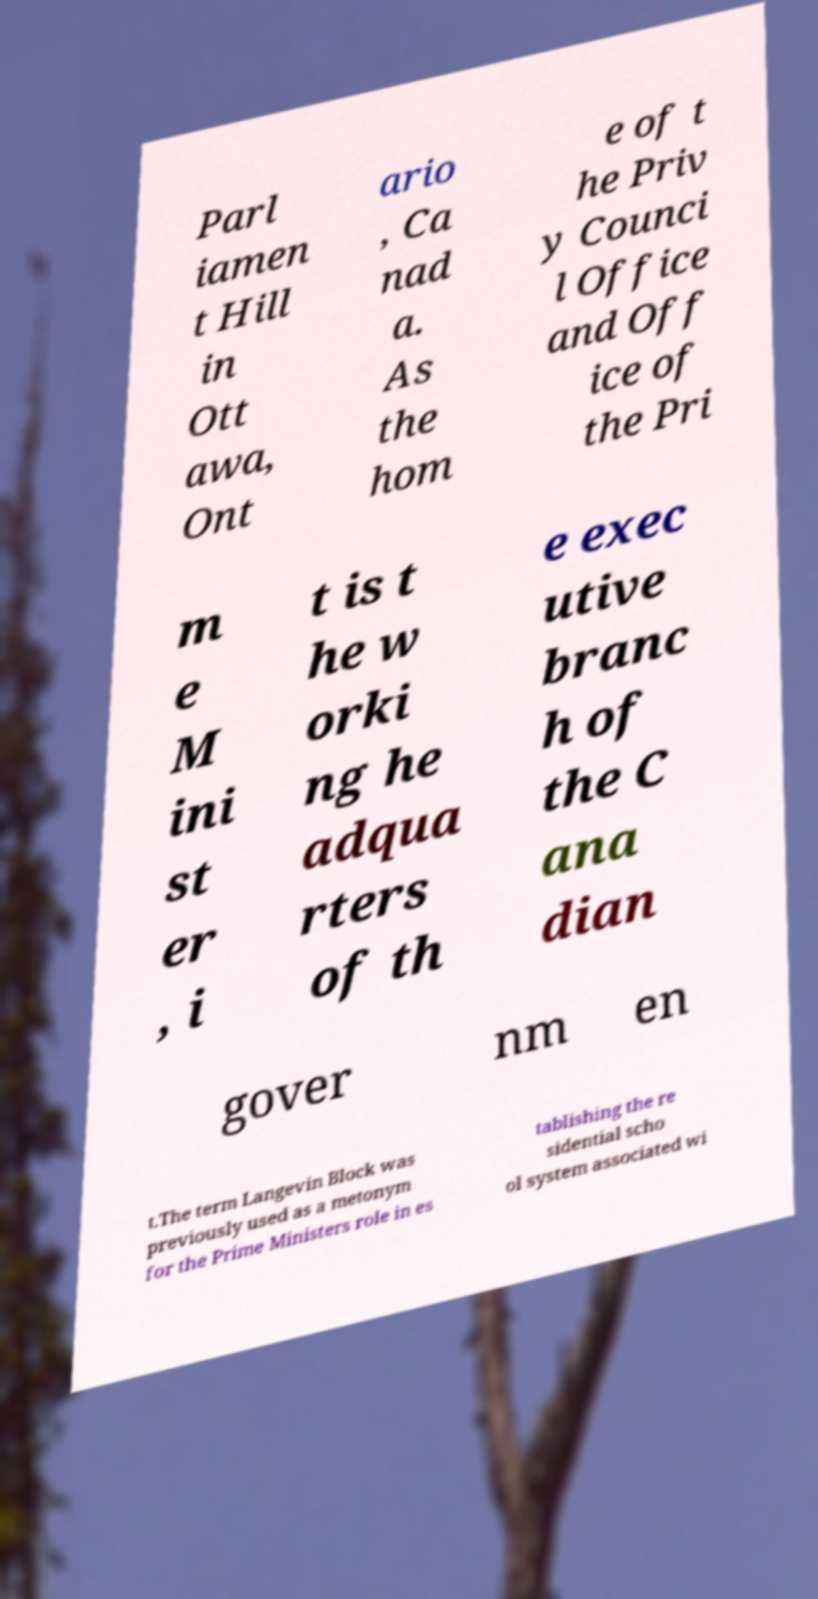Could you extract and type out the text from this image? Parl iamen t Hill in Ott awa, Ont ario , Ca nad a. As the hom e of t he Priv y Counci l Office and Off ice of the Pri m e M ini st er , i t is t he w orki ng he adqua rters of th e exec utive branc h of the C ana dian gover nm en t.The term Langevin Block was previously used as a metonym for the Prime Ministers role in es tablishing the re sidential scho ol system associated wi 